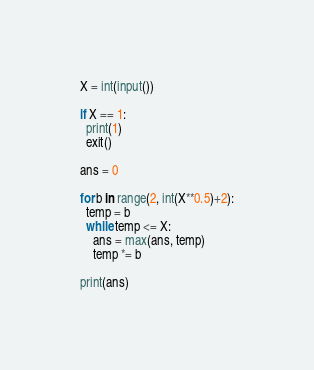<code> <loc_0><loc_0><loc_500><loc_500><_Python_>X = int(input())

if X == 1:
  print(1)
  exit()

ans = 0

for b in range(2, int(X**0.5)+2):
  temp = b
  while temp <= X:
    ans = max(ans, temp)
    temp *= b

print(ans)</code> 